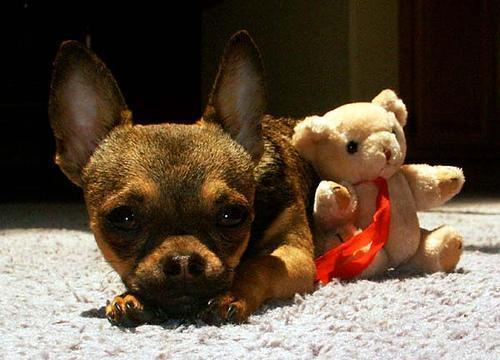How many dogs are there?
Give a very brief answer. 1. 